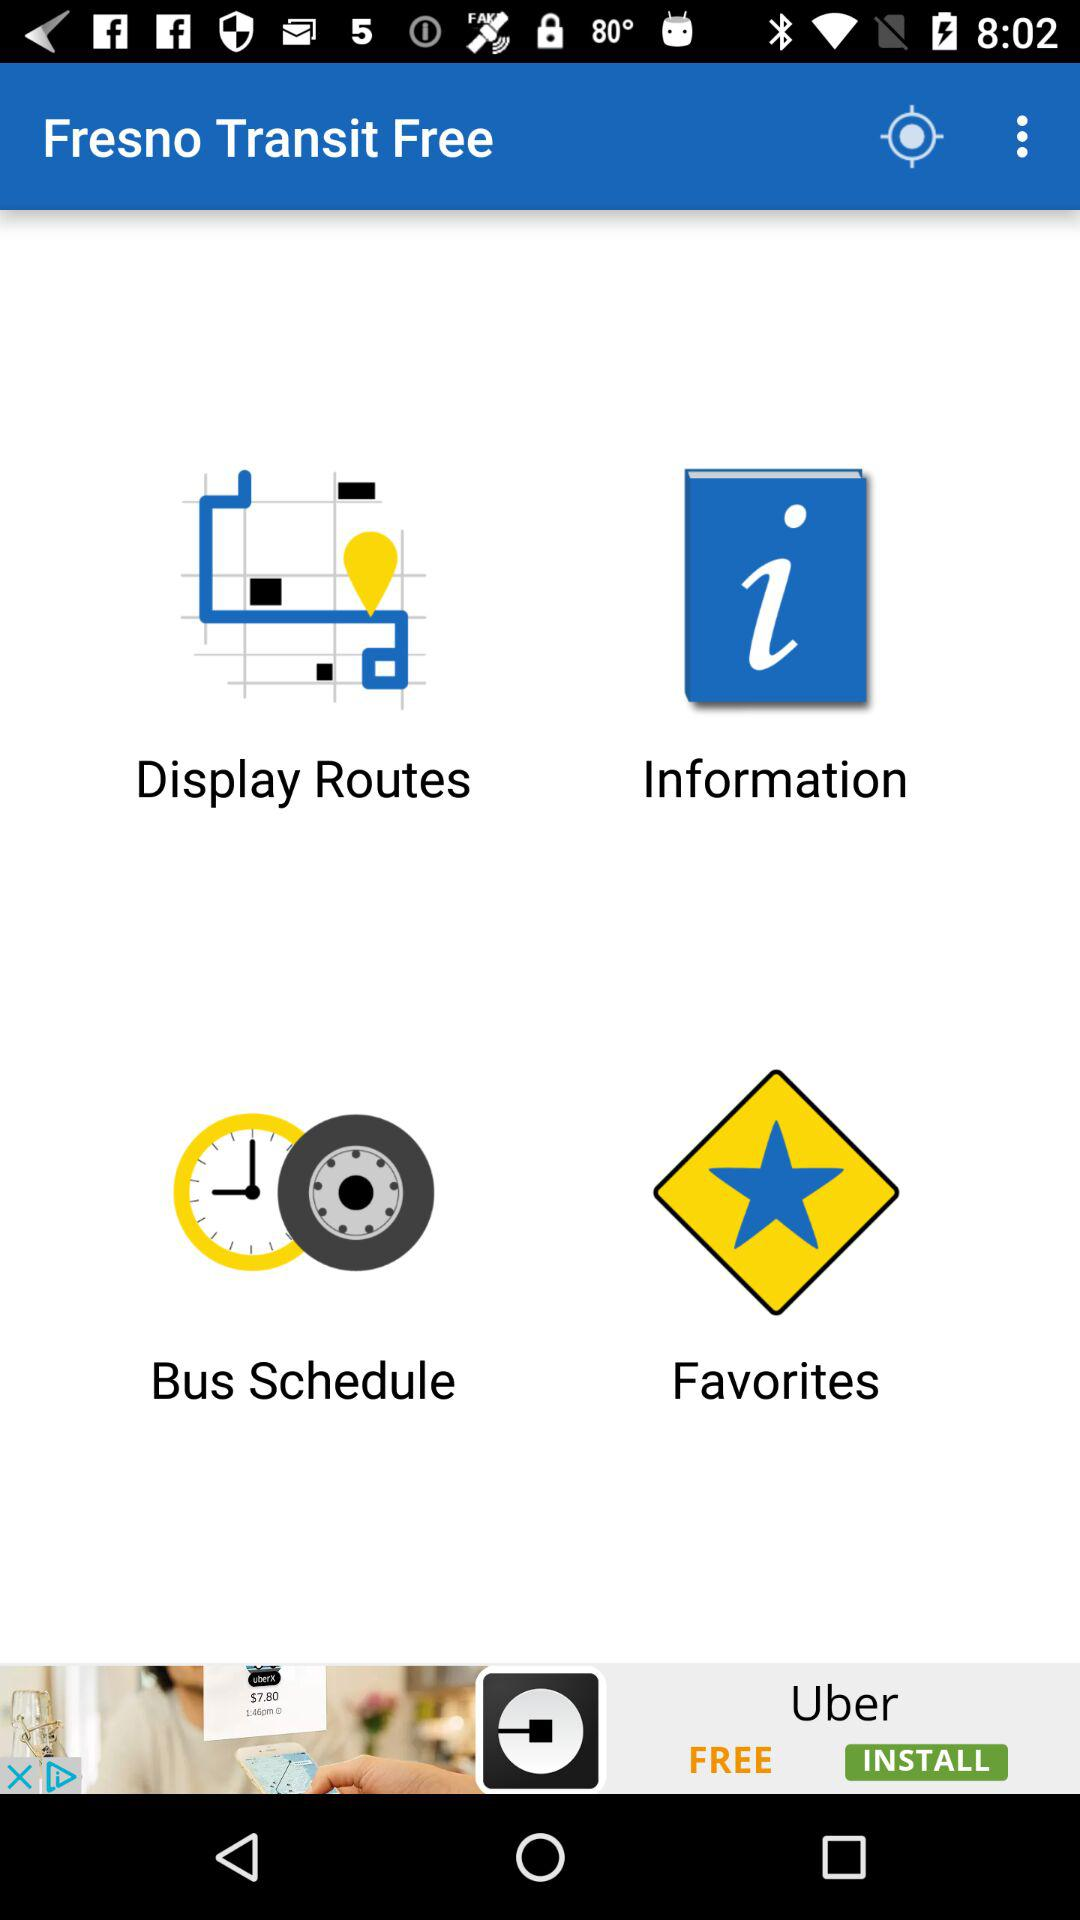What is the app name? The app name is "Fresno Transit Free". 